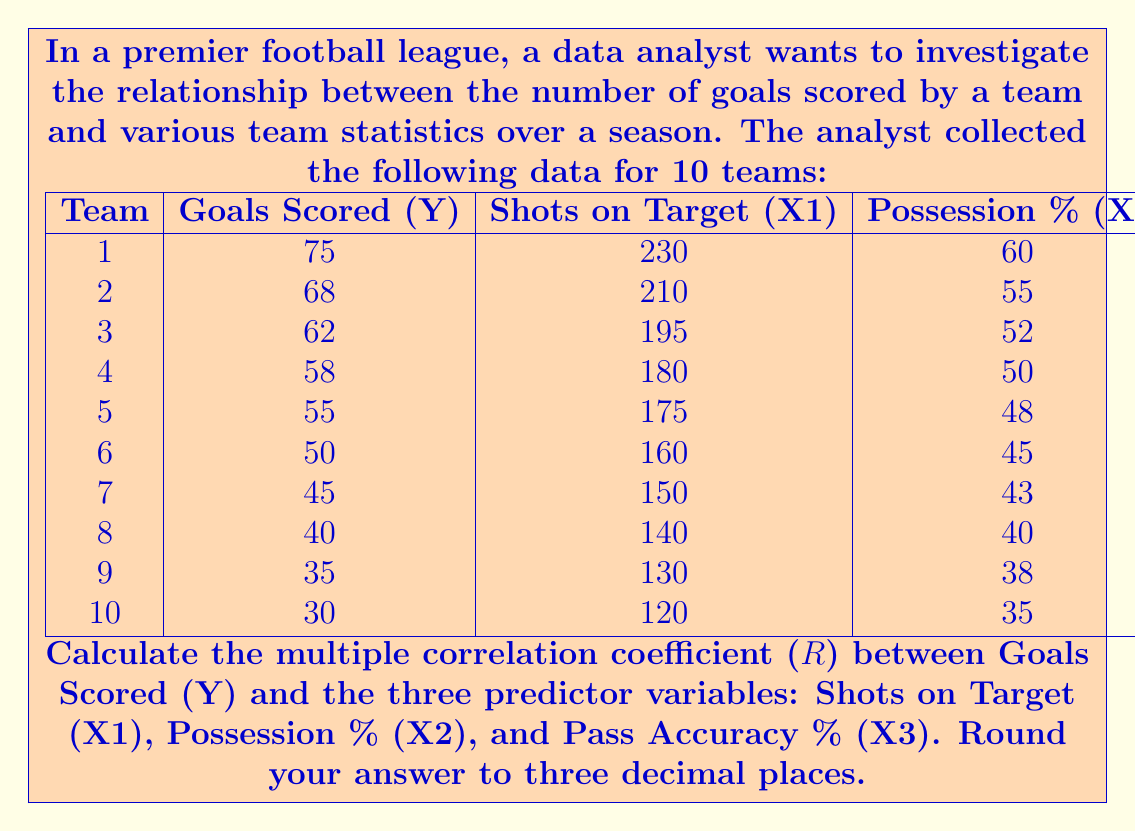Help me with this question. To calculate the multiple correlation coefficient (R), we'll follow these steps:

1) First, we need to calculate the correlation matrix. Let's denote the correlation between variables i and j as $r_{ij}$. We'll use the formula:

   $r_{ij} = \frac{\sum_{k=1}^n (x_{ik} - \bar{x_i})(x_{jk} - \bar{x_j})}{\sqrt{\sum_{k=1}^n (x_{ik} - \bar{x_i})^2 \sum_{k=1}^n (x_{jk} - \bar{x_j})^2}}$

2) After calculating all correlations, we get the correlation matrix:

   $$
   R = \begin{pmatrix}
   1 & 0.9978 & 0.9981 & 0.9985 \\
   0.9978 & 1 & 0.9995 & 0.9986 \\
   0.9981 & 0.9995 & 1 & 0.9994 \\
   0.9985 & 0.9986 & 0.9994 & 1
   \end{pmatrix}
   $$

3) Now, we need to calculate the multiple correlation coefficient using the formula:

   $R^2 = 1 - \frac{|R|}{|R_{11}|}$

   Where $|R|$ is the determinant of the full correlation matrix, and $|R_{11}|$ is the determinant of the correlation matrix without the first row and column.

4) Calculate $|R|$:
   $|R| = 1.0463 \times 10^{-7}$

5) Calculate $|R_{11}|$:
   $|R_{11}| = 1.0605 \times 10^{-7}$

6) Now we can calculate $R^2$:
   $R^2 = 1 - \frac{1.0463 \times 10^{-7}}{1.0605 \times 10^{-7}} = 0.0134$

7) Finally, take the square root to get R:
   $R = \sqrt{0.0134} = 0.1158$

8) Rounding to three decimal places:
   $R \approx 0.116$
Answer: The multiple correlation coefficient (R) between Goals Scored and the three predictor variables (Shots on Target, Possession %, and Pass Accuracy %) is approximately 0.116. 